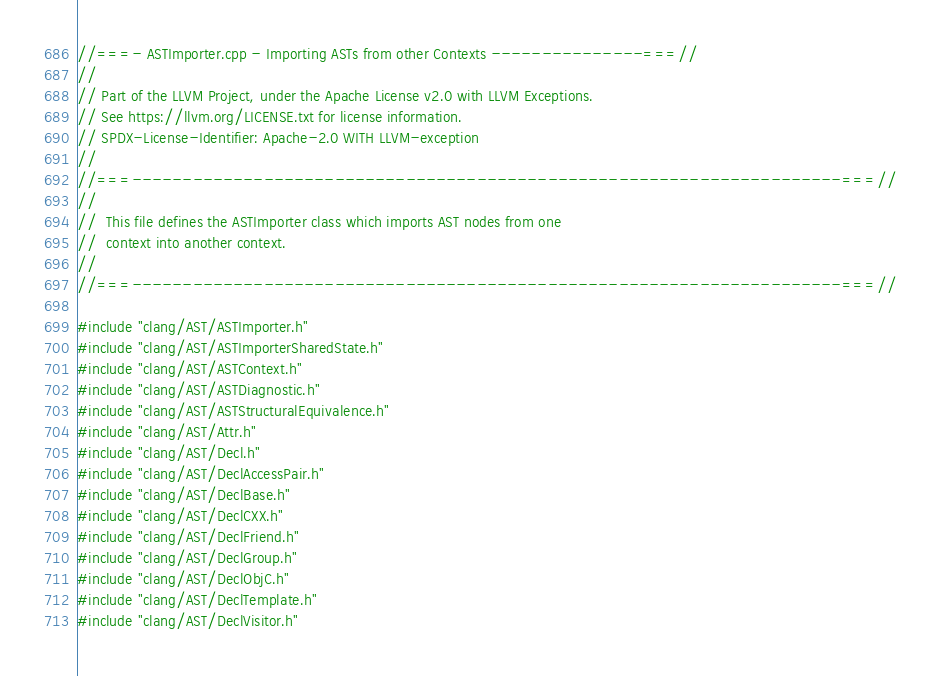<code> <loc_0><loc_0><loc_500><loc_500><_C++_>//===- ASTImporter.cpp - Importing ASTs from other Contexts ---------------===//
//
// Part of the LLVM Project, under the Apache License v2.0 with LLVM Exceptions.
// See https://llvm.org/LICENSE.txt for license information.
// SPDX-License-Identifier: Apache-2.0 WITH LLVM-exception
//
//===----------------------------------------------------------------------===//
//
//  This file defines the ASTImporter class which imports AST nodes from one
//  context into another context.
//
//===----------------------------------------------------------------------===//

#include "clang/AST/ASTImporter.h"
#include "clang/AST/ASTImporterSharedState.h"
#include "clang/AST/ASTContext.h"
#include "clang/AST/ASTDiagnostic.h"
#include "clang/AST/ASTStructuralEquivalence.h"
#include "clang/AST/Attr.h"
#include "clang/AST/Decl.h"
#include "clang/AST/DeclAccessPair.h"
#include "clang/AST/DeclBase.h"
#include "clang/AST/DeclCXX.h"
#include "clang/AST/DeclFriend.h"
#include "clang/AST/DeclGroup.h"
#include "clang/AST/DeclObjC.h"
#include "clang/AST/DeclTemplate.h"
#include "clang/AST/DeclVisitor.h"</code> 